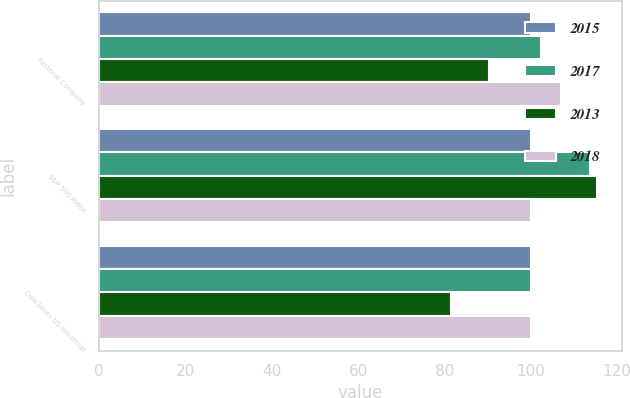Convert chart to OTSL. <chart><loc_0><loc_0><loc_500><loc_500><stacked_bar_chart><ecel><fcel>Fastenal Company<fcel>S&P 500 Index<fcel>Dow Jones US Industrial<nl><fcel>2015<fcel>100<fcel>100<fcel>100<nl><fcel>2017<fcel>102.36<fcel>113.69<fcel>99.94<nl><fcel>2013<fcel>90.26<fcel>115.26<fcel>81.47<nl><fcel>2018<fcel>106.97<fcel>100<fcel>100.08<nl></chart> 